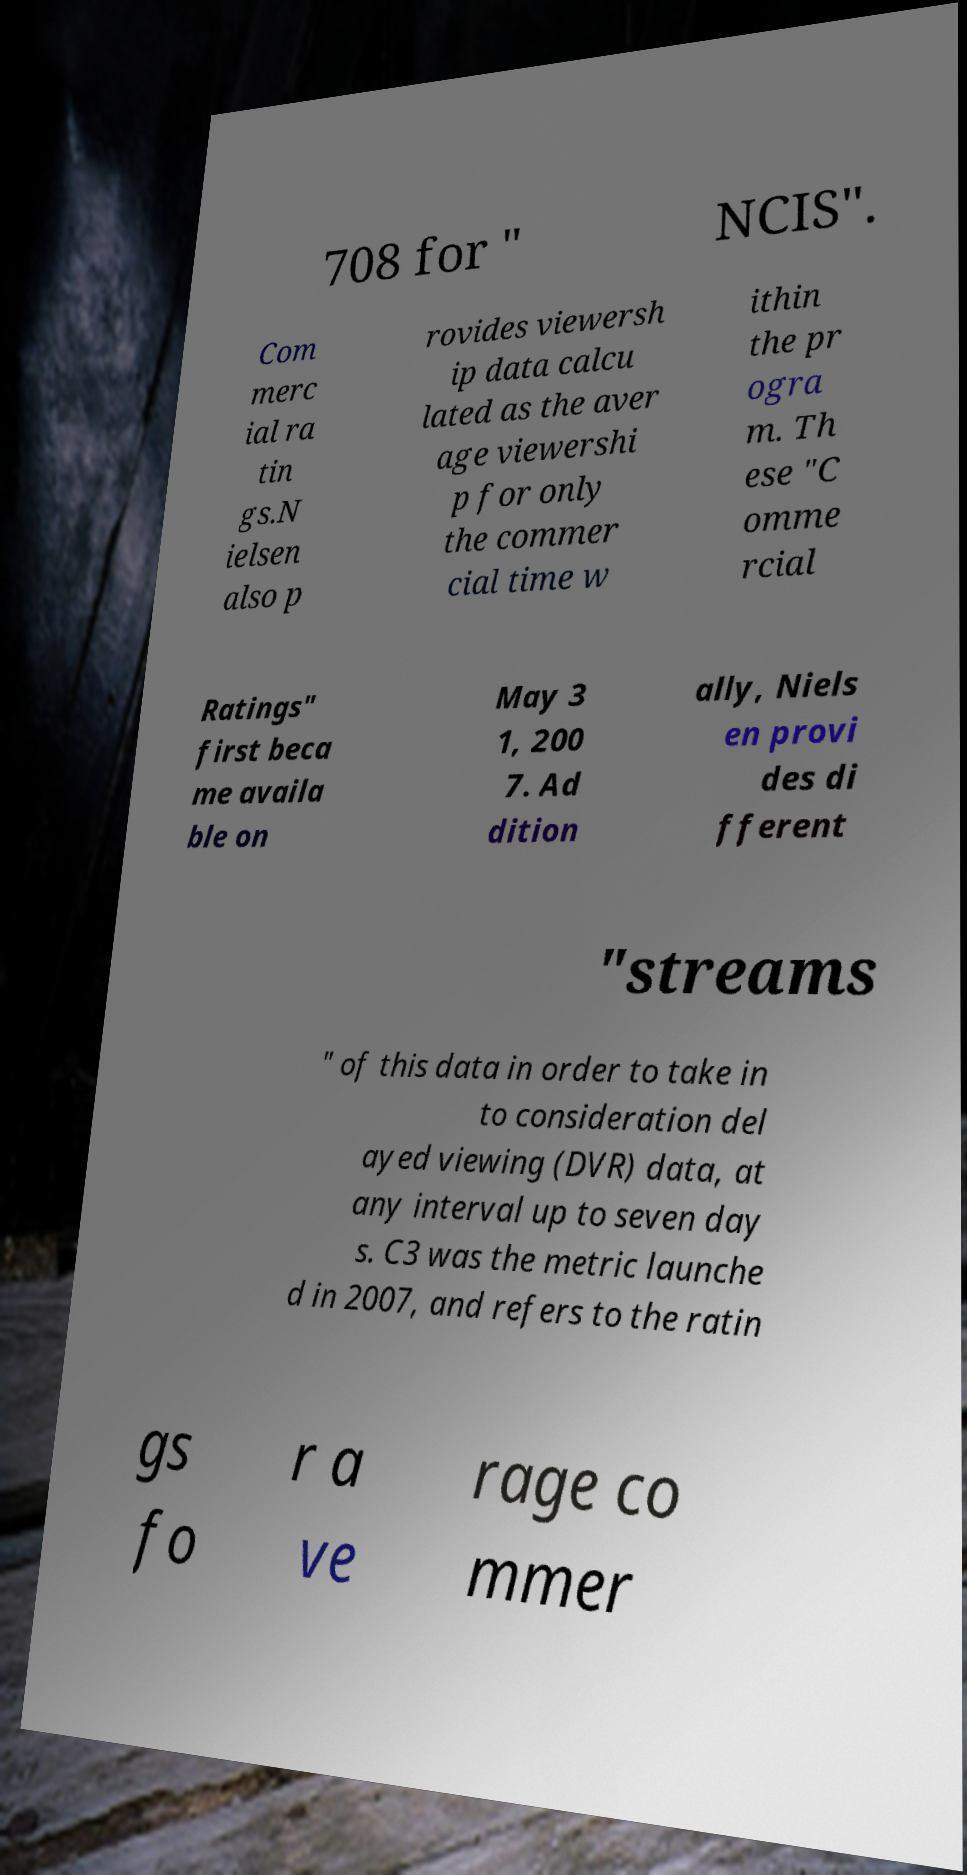There's text embedded in this image that I need extracted. Can you transcribe it verbatim? 708 for " NCIS". Com merc ial ra tin gs.N ielsen also p rovides viewersh ip data calcu lated as the aver age viewershi p for only the commer cial time w ithin the pr ogra m. Th ese "C omme rcial Ratings" first beca me availa ble on May 3 1, 200 7. Ad dition ally, Niels en provi des di fferent "streams " of this data in order to take in to consideration del ayed viewing (DVR) data, at any interval up to seven day s. C3 was the metric launche d in 2007, and refers to the ratin gs fo r a ve rage co mmer 